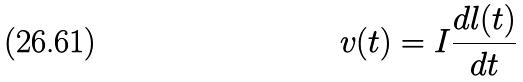Convert formula to latex. <formula><loc_0><loc_0><loc_500><loc_500>v ( t ) = I \frac { d l ( t ) } { d t }</formula> 